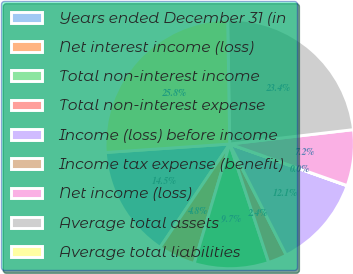<chart> <loc_0><loc_0><loc_500><loc_500><pie_chart><fcel>Years ended December 31 (in<fcel>Net interest income (loss)<fcel>Total non-interest income<fcel>Total non-interest expense<fcel>Income (loss) before income<fcel>Income tax expense (benefit)<fcel>Net income (loss)<fcel>Average total assets<fcel>Average total liabilities<nl><fcel>14.48%<fcel>4.84%<fcel>9.66%<fcel>2.43%<fcel>12.07%<fcel>0.03%<fcel>7.25%<fcel>23.42%<fcel>25.82%<nl></chart> 